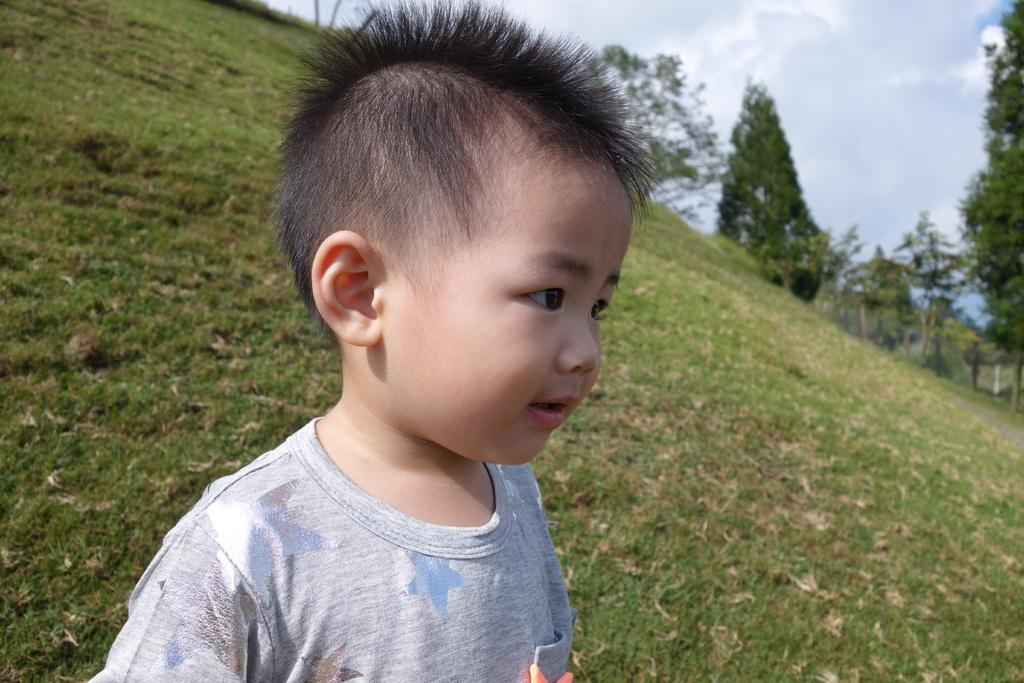Who is the main subject in the image? There is a boy in the image. What is the boy wearing? The boy is wearing a dress. What type of natural environment can be seen in the background of the image? There is grass, a group of trees, and the sky visible in the background of the image. What type of boundary can be seen in the image? There is no boundary present in the image. What shape is the cloud in the image? There is no cloud visible in the image. 